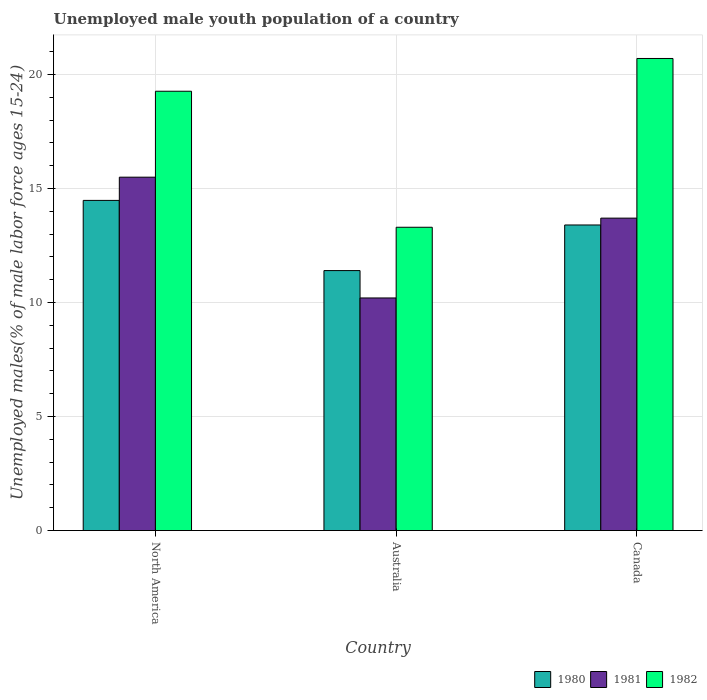How many groups of bars are there?
Make the answer very short. 3. Are the number of bars per tick equal to the number of legend labels?
Offer a terse response. Yes. Are the number of bars on each tick of the X-axis equal?
Ensure brevity in your answer.  Yes. How many bars are there on the 1st tick from the left?
Your answer should be compact. 3. How many bars are there on the 1st tick from the right?
Your answer should be very brief. 3. What is the label of the 1st group of bars from the left?
Offer a very short reply. North America. What is the percentage of unemployed male youth population in 1982 in North America?
Provide a short and direct response. 19.26. Across all countries, what is the maximum percentage of unemployed male youth population in 1981?
Ensure brevity in your answer.  15.5. Across all countries, what is the minimum percentage of unemployed male youth population in 1982?
Keep it short and to the point. 13.3. In which country was the percentage of unemployed male youth population in 1982 maximum?
Keep it short and to the point. Canada. What is the total percentage of unemployed male youth population in 1980 in the graph?
Make the answer very short. 39.28. What is the difference between the percentage of unemployed male youth population in 1981 in Australia and that in Canada?
Offer a terse response. -3.5. What is the difference between the percentage of unemployed male youth population in 1982 in North America and the percentage of unemployed male youth population in 1981 in Canada?
Your response must be concise. 5.56. What is the average percentage of unemployed male youth population in 1980 per country?
Make the answer very short. 13.09. What is the difference between the percentage of unemployed male youth population of/in 1982 and percentage of unemployed male youth population of/in 1980 in Canada?
Your answer should be very brief. 7.3. What is the ratio of the percentage of unemployed male youth population in 1981 in Australia to that in Canada?
Your answer should be compact. 0.74. What is the difference between the highest and the lowest percentage of unemployed male youth population in 1981?
Offer a terse response. 5.3. In how many countries, is the percentage of unemployed male youth population in 1982 greater than the average percentage of unemployed male youth population in 1982 taken over all countries?
Provide a short and direct response. 2. Is the sum of the percentage of unemployed male youth population in 1982 in Australia and Canada greater than the maximum percentage of unemployed male youth population in 1981 across all countries?
Your answer should be very brief. Yes. Is it the case that in every country, the sum of the percentage of unemployed male youth population in 1980 and percentage of unemployed male youth population in 1982 is greater than the percentage of unemployed male youth population in 1981?
Keep it short and to the point. Yes. Are the values on the major ticks of Y-axis written in scientific E-notation?
Ensure brevity in your answer.  No. Does the graph contain any zero values?
Provide a short and direct response. No. Does the graph contain grids?
Offer a terse response. Yes. What is the title of the graph?
Make the answer very short. Unemployed male youth population of a country. Does "1999" appear as one of the legend labels in the graph?
Give a very brief answer. No. What is the label or title of the Y-axis?
Keep it short and to the point. Unemployed males(% of male labor force ages 15-24). What is the Unemployed males(% of male labor force ages 15-24) of 1980 in North America?
Your answer should be very brief. 14.48. What is the Unemployed males(% of male labor force ages 15-24) in 1981 in North America?
Offer a very short reply. 15.5. What is the Unemployed males(% of male labor force ages 15-24) in 1982 in North America?
Offer a terse response. 19.26. What is the Unemployed males(% of male labor force ages 15-24) in 1980 in Australia?
Your answer should be compact. 11.4. What is the Unemployed males(% of male labor force ages 15-24) in 1981 in Australia?
Keep it short and to the point. 10.2. What is the Unemployed males(% of male labor force ages 15-24) in 1982 in Australia?
Give a very brief answer. 13.3. What is the Unemployed males(% of male labor force ages 15-24) in 1980 in Canada?
Your response must be concise. 13.4. What is the Unemployed males(% of male labor force ages 15-24) in 1981 in Canada?
Offer a terse response. 13.7. What is the Unemployed males(% of male labor force ages 15-24) of 1982 in Canada?
Your response must be concise. 20.7. Across all countries, what is the maximum Unemployed males(% of male labor force ages 15-24) of 1980?
Your answer should be very brief. 14.48. Across all countries, what is the maximum Unemployed males(% of male labor force ages 15-24) in 1981?
Your answer should be very brief. 15.5. Across all countries, what is the maximum Unemployed males(% of male labor force ages 15-24) in 1982?
Make the answer very short. 20.7. Across all countries, what is the minimum Unemployed males(% of male labor force ages 15-24) of 1980?
Offer a very short reply. 11.4. Across all countries, what is the minimum Unemployed males(% of male labor force ages 15-24) in 1981?
Ensure brevity in your answer.  10.2. Across all countries, what is the minimum Unemployed males(% of male labor force ages 15-24) in 1982?
Give a very brief answer. 13.3. What is the total Unemployed males(% of male labor force ages 15-24) of 1980 in the graph?
Offer a very short reply. 39.28. What is the total Unemployed males(% of male labor force ages 15-24) of 1981 in the graph?
Provide a short and direct response. 39.4. What is the total Unemployed males(% of male labor force ages 15-24) of 1982 in the graph?
Provide a succinct answer. 53.26. What is the difference between the Unemployed males(% of male labor force ages 15-24) in 1980 in North America and that in Australia?
Keep it short and to the point. 3.08. What is the difference between the Unemployed males(% of male labor force ages 15-24) in 1981 in North America and that in Australia?
Your answer should be very brief. 5.3. What is the difference between the Unemployed males(% of male labor force ages 15-24) in 1982 in North America and that in Australia?
Ensure brevity in your answer.  5.96. What is the difference between the Unemployed males(% of male labor force ages 15-24) of 1980 in North America and that in Canada?
Make the answer very short. 1.08. What is the difference between the Unemployed males(% of male labor force ages 15-24) of 1981 in North America and that in Canada?
Offer a terse response. 1.8. What is the difference between the Unemployed males(% of male labor force ages 15-24) of 1982 in North America and that in Canada?
Your answer should be very brief. -1.44. What is the difference between the Unemployed males(% of male labor force ages 15-24) of 1980 in Australia and that in Canada?
Your answer should be compact. -2. What is the difference between the Unemployed males(% of male labor force ages 15-24) of 1981 in Australia and that in Canada?
Your response must be concise. -3.5. What is the difference between the Unemployed males(% of male labor force ages 15-24) in 1980 in North America and the Unemployed males(% of male labor force ages 15-24) in 1981 in Australia?
Keep it short and to the point. 4.28. What is the difference between the Unemployed males(% of male labor force ages 15-24) of 1980 in North America and the Unemployed males(% of male labor force ages 15-24) of 1982 in Australia?
Your answer should be very brief. 1.18. What is the difference between the Unemployed males(% of male labor force ages 15-24) in 1981 in North America and the Unemployed males(% of male labor force ages 15-24) in 1982 in Australia?
Make the answer very short. 2.2. What is the difference between the Unemployed males(% of male labor force ages 15-24) in 1980 in North America and the Unemployed males(% of male labor force ages 15-24) in 1981 in Canada?
Your response must be concise. 0.78. What is the difference between the Unemployed males(% of male labor force ages 15-24) of 1980 in North America and the Unemployed males(% of male labor force ages 15-24) of 1982 in Canada?
Provide a short and direct response. -6.22. What is the difference between the Unemployed males(% of male labor force ages 15-24) of 1981 in North America and the Unemployed males(% of male labor force ages 15-24) of 1982 in Canada?
Provide a succinct answer. -5.2. What is the difference between the Unemployed males(% of male labor force ages 15-24) of 1980 in Australia and the Unemployed males(% of male labor force ages 15-24) of 1981 in Canada?
Give a very brief answer. -2.3. What is the average Unemployed males(% of male labor force ages 15-24) of 1980 per country?
Keep it short and to the point. 13.09. What is the average Unemployed males(% of male labor force ages 15-24) of 1981 per country?
Give a very brief answer. 13.13. What is the average Unemployed males(% of male labor force ages 15-24) of 1982 per country?
Keep it short and to the point. 17.75. What is the difference between the Unemployed males(% of male labor force ages 15-24) in 1980 and Unemployed males(% of male labor force ages 15-24) in 1981 in North America?
Give a very brief answer. -1.02. What is the difference between the Unemployed males(% of male labor force ages 15-24) of 1980 and Unemployed males(% of male labor force ages 15-24) of 1982 in North America?
Give a very brief answer. -4.79. What is the difference between the Unemployed males(% of male labor force ages 15-24) of 1981 and Unemployed males(% of male labor force ages 15-24) of 1982 in North America?
Your answer should be very brief. -3.77. What is the difference between the Unemployed males(% of male labor force ages 15-24) in 1980 and Unemployed males(% of male labor force ages 15-24) in 1981 in Australia?
Your response must be concise. 1.2. What is the difference between the Unemployed males(% of male labor force ages 15-24) in 1981 and Unemployed males(% of male labor force ages 15-24) in 1982 in Australia?
Provide a succinct answer. -3.1. What is the difference between the Unemployed males(% of male labor force ages 15-24) of 1980 and Unemployed males(% of male labor force ages 15-24) of 1981 in Canada?
Provide a short and direct response. -0.3. What is the ratio of the Unemployed males(% of male labor force ages 15-24) of 1980 in North America to that in Australia?
Provide a succinct answer. 1.27. What is the ratio of the Unemployed males(% of male labor force ages 15-24) of 1981 in North America to that in Australia?
Your answer should be very brief. 1.52. What is the ratio of the Unemployed males(% of male labor force ages 15-24) of 1982 in North America to that in Australia?
Your answer should be very brief. 1.45. What is the ratio of the Unemployed males(% of male labor force ages 15-24) in 1980 in North America to that in Canada?
Ensure brevity in your answer.  1.08. What is the ratio of the Unemployed males(% of male labor force ages 15-24) of 1981 in North America to that in Canada?
Offer a very short reply. 1.13. What is the ratio of the Unemployed males(% of male labor force ages 15-24) in 1982 in North America to that in Canada?
Your response must be concise. 0.93. What is the ratio of the Unemployed males(% of male labor force ages 15-24) of 1980 in Australia to that in Canada?
Your answer should be compact. 0.85. What is the ratio of the Unemployed males(% of male labor force ages 15-24) of 1981 in Australia to that in Canada?
Provide a succinct answer. 0.74. What is the ratio of the Unemployed males(% of male labor force ages 15-24) in 1982 in Australia to that in Canada?
Keep it short and to the point. 0.64. What is the difference between the highest and the second highest Unemployed males(% of male labor force ages 15-24) of 1980?
Provide a succinct answer. 1.08. What is the difference between the highest and the second highest Unemployed males(% of male labor force ages 15-24) in 1981?
Offer a terse response. 1.8. What is the difference between the highest and the second highest Unemployed males(% of male labor force ages 15-24) in 1982?
Give a very brief answer. 1.44. What is the difference between the highest and the lowest Unemployed males(% of male labor force ages 15-24) of 1980?
Give a very brief answer. 3.08. What is the difference between the highest and the lowest Unemployed males(% of male labor force ages 15-24) of 1981?
Ensure brevity in your answer.  5.3. What is the difference between the highest and the lowest Unemployed males(% of male labor force ages 15-24) in 1982?
Give a very brief answer. 7.4. 